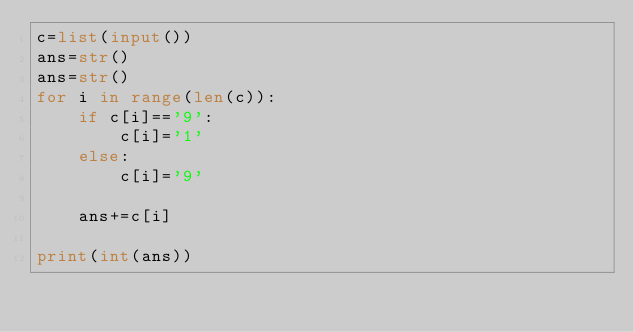Convert code to text. <code><loc_0><loc_0><loc_500><loc_500><_Python_>c=list(input())
ans=str()
ans=str()
for i in range(len(c)):
    if c[i]=='9':
        c[i]='1'
    else:
        c[i]='9'
        
    ans+=c[i]
    
print(int(ans))</code> 